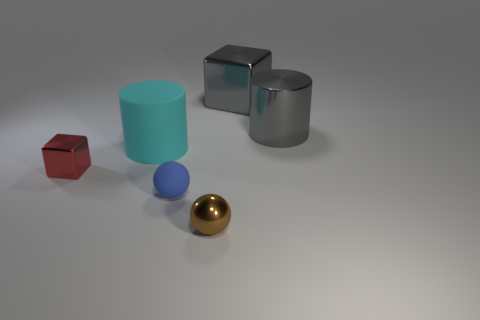Add 1 metallic balls. How many objects exist? 7 Subtract all blocks. How many objects are left? 4 Subtract all green metallic spheres. Subtract all small brown metallic balls. How many objects are left? 5 Add 3 blue matte objects. How many blue matte objects are left? 4 Add 2 big blue rubber spheres. How many big blue rubber spheres exist? 2 Subtract 1 gray cubes. How many objects are left? 5 